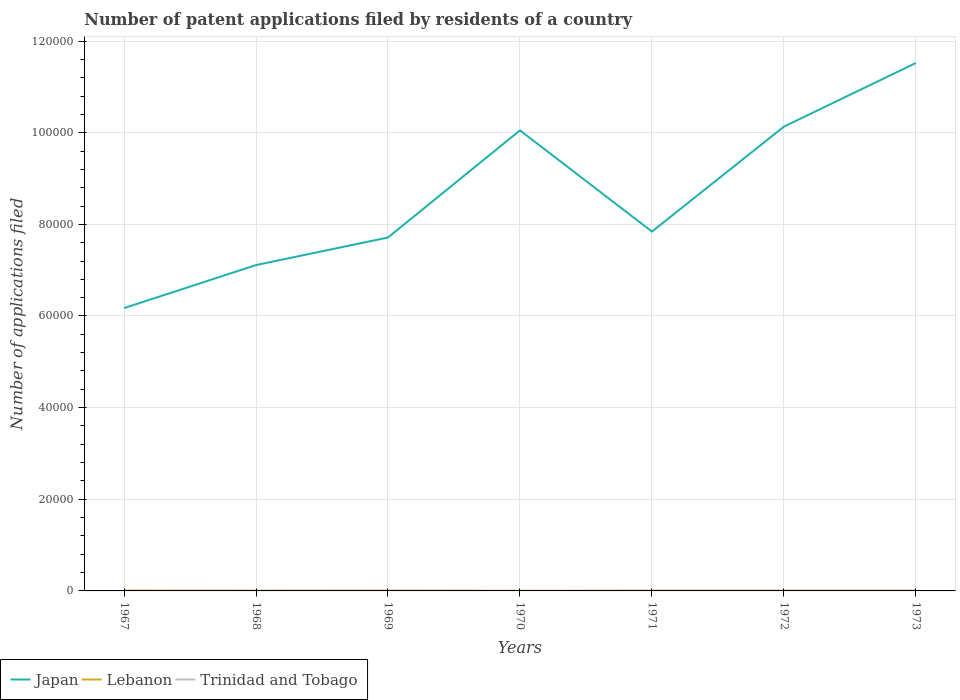How many different coloured lines are there?
Your answer should be compact. 3. Does the line corresponding to Trinidad and Tobago intersect with the line corresponding to Japan?
Offer a terse response. No. Across all years, what is the maximum number of applications filed in Japan?
Keep it short and to the point. 6.17e+04. In which year was the number of applications filed in Japan maximum?
Ensure brevity in your answer.  1967. What is the difference between the highest and the second highest number of applications filed in Trinidad and Tobago?
Your response must be concise. 6. Are the values on the major ticks of Y-axis written in scientific E-notation?
Provide a succinct answer. No. Does the graph contain grids?
Your answer should be very brief. Yes. Where does the legend appear in the graph?
Provide a succinct answer. Bottom left. How many legend labels are there?
Make the answer very short. 3. What is the title of the graph?
Provide a succinct answer. Number of patent applications filed by residents of a country. What is the label or title of the X-axis?
Offer a very short reply. Years. What is the label or title of the Y-axis?
Offer a terse response. Number of applications filed. What is the Number of applications filed of Japan in 1967?
Keep it short and to the point. 6.17e+04. What is the Number of applications filed of Lebanon in 1967?
Your response must be concise. 68. What is the Number of applications filed of Trinidad and Tobago in 1967?
Ensure brevity in your answer.  5. What is the Number of applications filed of Japan in 1968?
Ensure brevity in your answer.  7.11e+04. What is the Number of applications filed of Trinidad and Tobago in 1968?
Offer a very short reply. 2. What is the Number of applications filed in Japan in 1969?
Offer a very short reply. 7.71e+04. What is the Number of applications filed of Lebanon in 1969?
Offer a very short reply. 53. What is the Number of applications filed of Japan in 1970?
Keep it short and to the point. 1.01e+05. What is the Number of applications filed in Trinidad and Tobago in 1970?
Your answer should be compact. 4. What is the Number of applications filed in Japan in 1971?
Keep it short and to the point. 7.84e+04. What is the Number of applications filed of Lebanon in 1971?
Offer a terse response. 46. What is the Number of applications filed of Japan in 1972?
Your answer should be very brief. 1.01e+05. What is the Number of applications filed of Lebanon in 1972?
Your response must be concise. 47. What is the Number of applications filed in Japan in 1973?
Provide a short and direct response. 1.15e+05. What is the Number of applications filed of Trinidad and Tobago in 1973?
Your answer should be very brief. 6. Across all years, what is the maximum Number of applications filed in Japan?
Give a very brief answer. 1.15e+05. Across all years, what is the maximum Number of applications filed in Trinidad and Tobago?
Offer a very short reply. 8. Across all years, what is the minimum Number of applications filed in Japan?
Ensure brevity in your answer.  6.17e+04. Across all years, what is the minimum Number of applications filed of Lebanon?
Ensure brevity in your answer.  29. What is the total Number of applications filed in Japan in the graph?
Provide a short and direct response. 6.05e+05. What is the total Number of applications filed of Lebanon in the graph?
Your response must be concise. 331. What is the total Number of applications filed of Trinidad and Tobago in the graph?
Make the answer very short. 37. What is the difference between the Number of applications filed of Japan in 1967 and that in 1968?
Give a very brief answer. -9393. What is the difference between the Number of applications filed of Japan in 1967 and that in 1969?
Ensure brevity in your answer.  -1.54e+04. What is the difference between the Number of applications filed of Japan in 1967 and that in 1970?
Ensure brevity in your answer.  -3.88e+04. What is the difference between the Number of applications filed of Lebanon in 1967 and that in 1970?
Keep it short and to the point. 39. What is the difference between the Number of applications filed in Japan in 1967 and that in 1971?
Provide a short and direct response. -1.67e+04. What is the difference between the Number of applications filed in Lebanon in 1967 and that in 1971?
Your answer should be compact. 22. What is the difference between the Number of applications filed in Japan in 1967 and that in 1972?
Provide a succinct answer. -3.96e+04. What is the difference between the Number of applications filed in Lebanon in 1967 and that in 1972?
Offer a very short reply. 21. What is the difference between the Number of applications filed of Japan in 1967 and that in 1973?
Ensure brevity in your answer.  -5.35e+04. What is the difference between the Number of applications filed of Lebanon in 1967 and that in 1973?
Make the answer very short. 20. What is the difference between the Number of applications filed in Japan in 1968 and that in 1969?
Offer a very short reply. -6018. What is the difference between the Number of applications filed of Lebanon in 1968 and that in 1969?
Provide a short and direct response. -13. What is the difference between the Number of applications filed of Japan in 1968 and that in 1970?
Your response must be concise. -2.94e+04. What is the difference between the Number of applications filed of Japan in 1968 and that in 1971?
Make the answer very short. -7311. What is the difference between the Number of applications filed in Lebanon in 1968 and that in 1971?
Your response must be concise. -6. What is the difference between the Number of applications filed of Japan in 1968 and that in 1972?
Your answer should be compact. -3.02e+04. What is the difference between the Number of applications filed of Japan in 1968 and that in 1973?
Your response must be concise. -4.41e+04. What is the difference between the Number of applications filed in Lebanon in 1968 and that in 1973?
Your answer should be very brief. -8. What is the difference between the Number of applications filed in Trinidad and Tobago in 1968 and that in 1973?
Provide a short and direct response. -4. What is the difference between the Number of applications filed in Japan in 1969 and that in 1970?
Ensure brevity in your answer.  -2.34e+04. What is the difference between the Number of applications filed of Japan in 1969 and that in 1971?
Make the answer very short. -1293. What is the difference between the Number of applications filed in Lebanon in 1969 and that in 1971?
Make the answer very short. 7. What is the difference between the Number of applications filed in Japan in 1969 and that in 1972?
Make the answer very short. -2.42e+04. What is the difference between the Number of applications filed of Trinidad and Tobago in 1969 and that in 1972?
Provide a succinct answer. 0. What is the difference between the Number of applications filed of Japan in 1969 and that in 1973?
Make the answer very short. -3.81e+04. What is the difference between the Number of applications filed of Lebanon in 1969 and that in 1973?
Offer a very short reply. 5. What is the difference between the Number of applications filed in Trinidad and Tobago in 1969 and that in 1973?
Provide a short and direct response. 2. What is the difference between the Number of applications filed in Japan in 1970 and that in 1971?
Provide a succinct answer. 2.21e+04. What is the difference between the Number of applications filed in Lebanon in 1970 and that in 1971?
Ensure brevity in your answer.  -17. What is the difference between the Number of applications filed in Japan in 1970 and that in 1972?
Your answer should be compact. -815. What is the difference between the Number of applications filed of Trinidad and Tobago in 1970 and that in 1972?
Keep it short and to the point. -4. What is the difference between the Number of applications filed of Japan in 1970 and that in 1973?
Offer a very short reply. -1.47e+04. What is the difference between the Number of applications filed in Lebanon in 1970 and that in 1973?
Give a very brief answer. -19. What is the difference between the Number of applications filed in Trinidad and Tobago in 1970 and that in 1973?
Your response must be concise. -2. What is the difference between the Number of applications filed in Japan in 1971 and that in 1972?
Your answer should be very brief. -2.29e+04. What is the difference between the Number of applications filed of Lebanon in 1971 and that in 1972?
Your answer should be compact. -1. What is the difference between the Number of applications filed in Japan in 1971 and that in 1973?
Make the answer very short. -3.68e+04. What is the difference between the Number of applications filed of Japan in 1972 and that in 1973?
Offer a very short reply. -1.39e+04. What is the difference between the Number of applications filed in Lebanon in 1972 and that in 1973?
Provide a succinct answer. -1. What is the difference between the Number of applications filed in Trinidad and Tobago in 1972 and that in 1973?
Give a very brief answer. 2. What is the difference between the Number of applications filed of Japan in 1967 and the Number of applications filed of Lebanon in 1968?
Ensure brevity in your answer.  6.17e+04. What is the difference between the Number of applications filed of Japan in 1967 and the Number of applications filed of Trinidad and Tobago in 1968?
Provide a succinct answer. 6.17e+04. What is the difference between the Number of applications filed of Lebanon in 1967 and the Number of applications filed of Trinidad and Tobago in 1968?
Your answer should be very brief. 66. What is the difference between the Number of applications filed in Japan in 1967 and the Number of applications filed in Lebanon in 1969?
Provide a succinct answer. 6.17e+04. What is the difference between the Number of applications filed of Japan in 1967 and the Number of applications filed of Trinidad and Tobago in 1969?
Offer a very short reply. 6.17e+04. What is the difference between the Number of applications filed of Japan in 1967 and the Number of applications filed of Lebanon in 1970?
Provide a short and direct response. 6.17e+04. What is the difference between the Number of applications filed of Japan in 1967 and the Number of applications filed of Trinidad and Tobago in 1970?
Provide a short and direct response. 6.17e+04. What is the difference between the Number of applications filed in Japan in 1967 and the Number of applications filed in Lebanon in 1971?
Offer a terse response. 6.17e+04. What is the difference between the Number of applications filed of Japan in 1967 and the Number of applications filed of Trinidad and Tobago in 1971?
Offer a terse response. 6.17e+04. What is the difference between the Number of applications filed of Lebanon in 1967 and the Number of applications filed of Trinidad and Tobago in 1971?
Make the answer very short. 64. What is the difference between the Number of applications filed in Japan in 1967 and the Number of applications filed in Lebanon in 1972?
Your response must be concise. 6.17e+04. What is the difference between the Number of applications filed of Japan in 1967 and the Number of applications filed of Trinidad and Tobago in 1972?
Offer a very short reply. 6.17e+04. What is the difference between the Number of applications filed in Lebanon in 1967 and the Number of applications filed in Trinidad and Tobago in 1972?
Provide a succinct answer. 60. What is the difference between the Number of applications filed in Japan in 1967 and the Number of applications filed in Lebanon in 1973?
Offer a terse response. 6.17e+04. What is the difference between the Number of applications filed of Japan in 1967 and the Number of applications filed of Trinidad and Tobago in 1973?
Provide a succinct answer. 6.17e+04. What is the difference between the Number of applications filed of Lebanon in 1967 and the Number of applications filed of Trinidad and Tobago in 1973?
Give a very brief answer. 62. What is the difference between the Number of applications filed of Japan in 1968 and the Number of applications filed of Lebanon in 1969?
Your response must be concise. 7.11e+04. What is the difference between the Number of applications filed of Japan in 1968 and the Number of applications filed of Trinidad and Tobago in 1969?
Provide a short and direct response. 7.11e+04. What is the difference between the Number of applications filed in Lebanon in 1968 and the Number of applications filed in Trinidad and Tobago in 1969?
Ensure brevity in your answer.  32. What is the difference between the Number of applications filed of Japan in 1968 and the Number of applications filed of Lebanon in 1970?
Your response must be concise. 7.11e+04. What is the difference between the Number of applications filed of Japan in 1968 and the Number of applications filed of Trinidad and Tobago in 1970?
Your response must be concise. 7.11e+04. What is the difference between the Number of applications filed of Lebanon in 1968 and the Number of applications filed of Trinidad and Tobago in 1970?
Ensure brevity in your answer.  36. What is the difference between the Number of applications filed in Japan in 1968 and the Number of applications filed in Lebanon in 1971?
Provide a short and direct response. 7.11e+04. What is the difference between the Number of applications filed in Japan in 1968 and the Number of applications filed in Trinidad and Tobago in 1971?
Offer a terse response. 7.11e+04. What is the difference between the Number of applications filed of Lebanon in 1968 and the Number of applications filed of Trinidad and Tobago in 1971?
Your response must be concise. 36. What is the difference between the Number of applications filed in Japan in 1968 and the Number of applications filed in Lebanon in 1972?
Provide a short and direct response. 7.11e+04. What is the difference between the Number of applications filed in Japan in 1968 and the Number of applications filed in Trinidad and Tobago in 1972?
Give a very brief answer. 7.11e+04. What is the difference between the Number of applications filed of Lebanon in 1968 and the Number of applications filed of Trinidad and Tobago in 1972?
Give a very brief answer. 32. What is the difference between the Number of applications filed of Japan in 1968 and the Number of applications filed of Lebanon in 1973?
Provide a succinct answer. 7.11e+04. What is the difference between the Number of applications filed in Japan in 1968 and the Number of applications filed in Trinidad and Tobago in 1973?
Provide a succinct answer. 7.11e+04. What is the difference between the Number of applications filed in Lebanon in 1968 and the Number of applications filed in Trinidad and Tobago in 1973?
Provide a short and direct response. 34. What is the difference between the Number of applications filed of Japan in 1969 and the Number of applications filed of Lebanon in 1970?
Your answer should be compact. 7.71e+04. What is the difference between the Number of applications filed in Japan in 1969 and the Number of applications filed in Trinidad and Tobago in 1970?
Your answer should be compact. 7.71e+04. What is the difference between the Number of applications filed of Lebanon in 1969 and the Number of applications filed of Trinidad and Tobago in 1970?
Keep it short and to the point. 49. What is the difference between the Number of applications filed of Japan in 1969 and the Number of applications filed of Lebanon in 1971?
Ensure brevity in your answer.  7.71e+04. What is the difference between the Number of applications filed in Japan in 1969 and the Number of applications filed in Trinidad and Tobago in 1971?
Keep it short and to the point. 7.71e+04. What is the difference between the Number of applications filed of Lebanon in 1969 and the Number of applications filed of Trinidad and Tobago in 1971?
Provide a succinct answer. 49. What is the difference between the Number of applications filed in Japan in 1969 and the Number of applications filed in Lebanon in 1972?
Your answer should be very brief. 7.71e+04. What is the difference between the Number of applications filed in Japan in 1969 and the Number of applications filed in Trinidad and Tobago in 1972?
Your response must be concise. 7.71e+04. What is the difference between the Number of applications filed of Japan in 1969 and the Number of applications filed of Lebanon in 1973?
Ensure brevity in your answer.  7.71e+04. What is the difference between the Number of applications filed of Japan in 1969 and the Number of applications filed of Trinidad and Tobago in 1973?
Provide a short and direct response. 7.71e+04. What is the difference between the Number of applications filed in Lebanon in 1969 and the Number of applications filed in Trinidad and Tobago in 1973?
Your answer should be compact. 47. What is the difference between the Number of applications filed in Japan in 1970 and the Number of applications filed in Lebanon in 1971?
Your answer should be very brief. 1.00e+05. What is the difference between the Number of applications filed of Japan in 1970 and the Number of applications filed of Trinidad and Tobago in 1971?
Offer a very short reply. 1.01e+05. What is the difference between the Number of applications filed in Lebanon in 1970 and the Number of applications filed in Trinidad and Tobago in 1971?
Your answer should be compact. 25. What is the difference between the Number of applications filed of Japan in 1970 and the Number of applications filed of Lebanon in 1972?
Give a very brief answer. 1.00e+05. What is the difference between the Number of applications filed in Japan in 1970 and the Number of applications filed in Trinidad and Tobago in 1972?
Make the answer very short. 1.01e+05. What is the difference between the Number of applications filed in Japan in 1970 and the Number of applications filed in Lebanon in 1973?
Provide a succinct answer. 1.00e+05. What is the difference between the Number of applications filed in Japan in 1970 and the Number of applications filed in Trinidad and Tobago in 1973?
Ensure brevity in your answer.  1.01e+05. What is the difference between the Number of applications filed in Lebanon in 1970 and the Number of applications filed in Trinidad and Tobago in 1973?
Make the answer very short. 23. What is the difference between the Number of applications filed in Japan in 1971 and the Number of applications filed in Lebanon in 1972?
Ensure brevity in your answer.  7.84e+04. What is the difference between the Number of applications filed of Japan in 1971 and the Number of applications filed of Trinidad and Tobago in 1972?
Offer a terse response. 7.84e+04. What is the difference between the Number of applications filed in Japan in 1971 and the Number of applications filed in Lebanon in 1973?
Offer a terse response. 7.84e+04. What is the difference between the Number of applications filed in Japan in 1971 and the Number of applications filed in Trinidad and Tobago in 1973?
Your answer should be very brief. 7.84e+04. What is the difference between the Number of applications filed of Japan in 1972 and the Number of applications filed of Lebanon in 1973?
Your answer should be very brief. 1.01e+05. What is the difference between the Number of applications filed in Japan in 1972 and the Number of applications filed in Trinidad and Tobago in 1973?
Keep it short and to the point. 1.01e+05. What is the difference between the Number of applications filed of Lebanon in 1972 and the Number of applications filed of Trinidad and Tobago in 1973?
Provide a succinct answer. 41. What is the average Number of applications filed of Japan per year?
Give a very brief answer. 8.65e+04. What is the average Number of applications filed in Lebanon per year?
Your response must be concise. 47.29. What is the average Number of applications filed of Trinidad and Tobago per year?
Provide a short and direct response. 5.29. In the year 1967, what is the difference between the Number of applications filed of Japan and Number of applications filed of Lebanon?
Your response must be concise. 6.17e+04. In the year 1967, what is the difference between the Number of applications filed of Japan and Number of applications filed of Trinidad and Tobago?
Make the answer very short. 6.17e+04. In the year 1967, what is the difference between the Number of applications filed of Lebanon and Number of applications filed of Trinidad and Tobago?
Offer a very short reply. 63. In the year 1968, what is the difference between the Number of applications filed in Japan and Number of applications filed in Lebanon?
Make the answer very short. 7.11e+04. In the year 1968, what is the difference between the Number of applications filed in Japan and Number of applications filed in Trinidad and Tobago?
Ensure brevity in your answer.  7.11e+04. In the year 1968, what is the difference between the Number of applications filed in Lebanon and Number of applications filed in Trinidad and Tobago?
Make the answer very short. 38. In the year 1969, what is the difference between the Number of applications filed of Japan and Number of applications filed of Lebanon?
Your answer should be compact. 7.71e+04. In the year 1969, what is the difference between the Number of applications filed of Japan and Number of applications filed of Trinidad and Tobago?
Your response must be concise. 7.71e+04. In the year 1970, what is the difference between the Number of applications filed of Japan and Number of applications filed of Lebanon?
Ensure brevity in your answer.  1.00e+05. In the year 1970, what is the difference between the Number of applications filed of Japan and Number of applications filed of Trinidad and Tobago?
Provide a succinct answer. 1.01e+05. In the year 1971, what is the difference between the Number of applications filed in Japan and Number of applications filed in Lebanon?
Offer a terse response. 7.84e+04. In the year 1971, what is the difference between the Number of applications filed of Japan and Number of applications filed of Trinidad and Tobago?
Your answer should be compact. 7.84e+04. In the year 1971, what is the difference between the Number of applications filed in Lebanon and Number of applications filed in Trinidad and Tobago?
Your response must be concise. 42. In the year 1972, what is the difference between the Number of applications filed in Japan and Number of applications filed in Lebanon?
Provide a short and direct response. 1.01e+05. In the year 1972, what is the difference between the Number of applications filed of Japan and Number of applications filed of Trinidad and Tobago?
Provide a short and direct response. 1.01e+05. In the year 1972, what is the difference between the Number of applications filed of Lebanon and Number of applications filed of Trinidad and Tobago?
Make the answer very short. 39. In the year 1973, what is the difference between the Number of applications filed in Japan and Number of applications filed in Lebanon?
Your answer should be very brief. 1.15e+05. In the year 1973, what is the difference between the Number of applications filed of Japan and Number of applications filed of Trinidad and Tobago?
Your response must be concise. 1.15e+05. What is the ratio of the Number of applications filed of Japan in 1967 to that in 1968?
Offer a very short reply. 0.87. What is the ratio of the Number of applications filed of Trinidad and Tobago in 1967 to that in 1968?
Provide a short and direct response. 2.5. What is the ratio of the Number of applications filed in Japan in 1967 to that in 1969?
Make the answer very short. 0.8. What is the ratio of the Number of applications filed of Lebanon in 1967 to that in 1969?
Offer a very short reply. 1.28. What is the ratio of the Number of applications filed in Trinidad and Tobago in 1967 to that in 1969?
Offer a terse response. 0.62. What is the ratio of the Number of applications filed in Japan in 1967 to that in 1970?
Ensure brevity in your answer.  0.61. What is the ratio of the Number of applications filed in Lebanon in 1967 to that in 1970?
Offer a terse response. 2.34. What is the ratio of the Number of applications filed of Japan in 1967 to that in 1971?
Give a very brief answer. 0.79. What is the ratio of the Number of applications filed in Lebanon in 1967 to that in 1971?
Offer a very short reply. 1.48. What is the ratio of the Number of applications filed in Japan in 1967 to that in 1972?
Provide a succinct answer. 0.61. What is the ratio of the Number of applications filed in Lebanon in 1967 to that in 1972?
Keep it short and to the point. 1.45. What is the ratio of the Number of applications filed of Japan in 1967 to that in 1973?
Provide a short and direct response. 0.54. What is the ratio of the Number of applications filed in Lebanon in 1967 to that in 1973?
Offer a very short reply. 1.42. What is the ratio of the Number of applications filed in Japan in 1968 to that in 1969?
Your answer should be compact. 0.92. What is the ratio of the Number of applications filed of Lebanon in 1968 to that in 1969?
Give a very brief answer. 0.75. What is the ratio of the Number of applications filed of Trinidad and Tobago in 1968 to that in 1969?
Your answer should be compact. 0.25. What is the ratio of the Number of applications filed in Japan in 1968 to that in 1970?
Provide a short and direct response. 0.71. What is the ratio of the Number of applications filed of Lebanon in 1968 to that in 1970?
Keep it short and to the point. 1.38. What is the ratio of the Number of applications filed in Trinidad and Tobago in 1968 to that in 1970?
Provide a succinct answer. 0.5. What is the ratio of the Number of applications filed of Japan in 1968 to that in 1971?
Provide a succinct answer. 0.91. What is the ratio of the Number of applications filed in Lebanon in 1968 to that in 1971?
Your response must be concise. 0.87. What is the ratio of the Number of applications filed of Trinidad and Tobago in 1968 to that in 1971?
Offer a very short reply. 0.5. What is the ratio of the Number of applications filed in Japan in 1968 to that in 1972?
Provide a succinct answer. 0.7. What is the ratio of the Number of applications filed in Lebanon in 1968 to that in 1972?
Your answer should be very brief. 0.85. What is the ratio of the Number of applications filed in Japan in 1968 to that in 1973?
Offer a very short reply. 0.62. What is the ratio of the Number of applications filed of Japan in 1969 to that in 1970?
Provide a short and direct response. 0.77. What is the ratio of the Number of applications filed of Lebanon in 1969 to that in 1970?
Provide a succinct answer. 1.83. What is the ratio of the Number of applications filed of Trinidad and Tobago in 1969 to that in 1970?
Ensure brevity in your answer.  2. What is the ratio of the Number of applications filed of Japan in 1969 to that in 1971?
Make the answer very short. 0.98. What is the ratio of the Number of applications filed of Lebanon in 1969 to that in 1971?
Your answer should be compact. 1.15. What is the ratio of the Number of applications filed of Trinidad and Tobago in 1969 to that in 1971?
Offer a terse response. 2. What is the ratio of the Number of applications filed of Japan in 1969 to that in 1972?
Give a very brief answer. 0.76. What is the ratio of the Number of applications filed of Lebanon in 1969 to that in 1972?
Keep it short and to the point. 1.13. What is the ratio of the Number of applications filed of Trinidad and Tobago in 1969 to that in 1972?
Make the answer very short. 1. What is the ratio of the Number of applications filed of Japan in 1969 to that in 1973?
Ensure brevity in your answer.  0.67. What is the ratio of the Number of applications filed in Lebanon in 1969 to that in 1973?
Your response must be concise. 1.1. What is the ratio of the Number of applications filed of Japan in 1970 to that in 1971?
Offer a very short reply. 1.28. What is the ratio of the Number of applications filed of Lebanon in 1970 to that in 1971?
Provide a succinct answer. 0.63. What is the ratio of the Number of applications filed in Trinidad and Tobago in 1970 to that in 1971?
Give a very brief answer. 1. What is the ratio of the Number of applications filed of Japan in 1970 to that in 1972?
Make the answer very short. 0.99. What is the ratio of the Number of applications filed in Lebanon in 1970 to that in 1972?
Ensure brevity in your answer.  0.62. What is the ratio of the Number of applications filed of Japan in 1970 to that in 1973?
Your answer should be very brief. 0.87. What is the ratio of the Number of applications filed of Lebanon in 1970 to that in 1973?
Give a very brief answer. 0.6. What is the ratio of the Number of applications filed in Trinidad and Tobago in 1970 to that in 1973?
Your response must be concise. 0.67. What is the ratio of the Number of applications filed of Japan in 1971 to that in 1972?
Your response must be concise. 0.77. What is the ratio of the Number of applications filed of Lebanon in 1971 to that in 1972?
Offer a terse response. 0.98. What is the ratio of the Number of applications filed in Trinidad and Tobago in 1971 to that in 1972?
Provide a succinct answer. 0.5. What is the ratio of the Number of applications filed of Japan in 1971 to that in 1973?
Your response must be concise. 0.68. What is the ratio of the Number of applications filed of Lebanon in 1971 to that in 1973?
Give a very brief answer. 0.96. What is the ratio of the Number of applications filed in Japan in 1972 to that in 1973?
Give a very brief answer. 0.88. What is the ratio of the Number of applications filed of Lebanon in 1972 to that in 1973?
Offer a terse response. 0.98. What is the difference between the highest and the second highest Number of applications filed of Japan?
Offer a terse response. 1.39e+04. What is the difference between the highest and the lowest Number of applications filed in Japan?
Provide a short and direct response. 5.35e+04. What is the difference between the highest and the lowest Number of applications filed in Lebanon?
Offer a terse response. 39. 